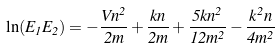Convert formula to latex. <formula><loc_0><loc_0><loc_500><loc_500>\ln ( E _ { 1 } E _ { 2 } ) = - \frac { V n ^ { 2 } } { 2 m } + \frac { k n } { 2 m } + \frac { 5 k n ^ { 2 } } { 1 2 m ^ { 2 } } - \frac { k ^ { 2 } n } { 4 m ^ { 2 } }</formula> 